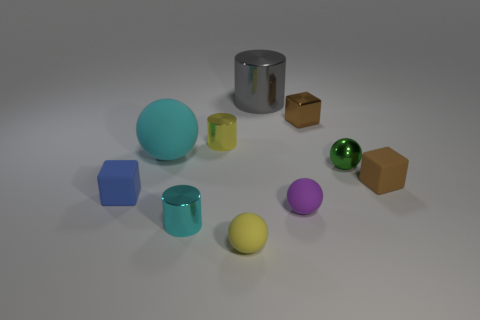Subtract all green cubes. How many red balls are left? 0 Subtract all tiny red rubber balls. Subtract all brown rubber things. How many objects are left? 9 Add 5 matte spheres. How many matte spheres are left? 8 Add 7 large cyan rubber balls. How many large cyan rubber balls exist? 8 Subtract all blue blocks. How many blocks are left? 2 Subtract all tiny shiny cylinders. How many cylinders are left? 1 Subtract 0 purple blocks. How many objects are left? 10 Subtract all cubes. How many objects are left? 7 Subtract 3 cylinders. How many cylinders are left? 0 Subtract all blue spheres. Subtract all red blocks. How many spheres are left? 4 